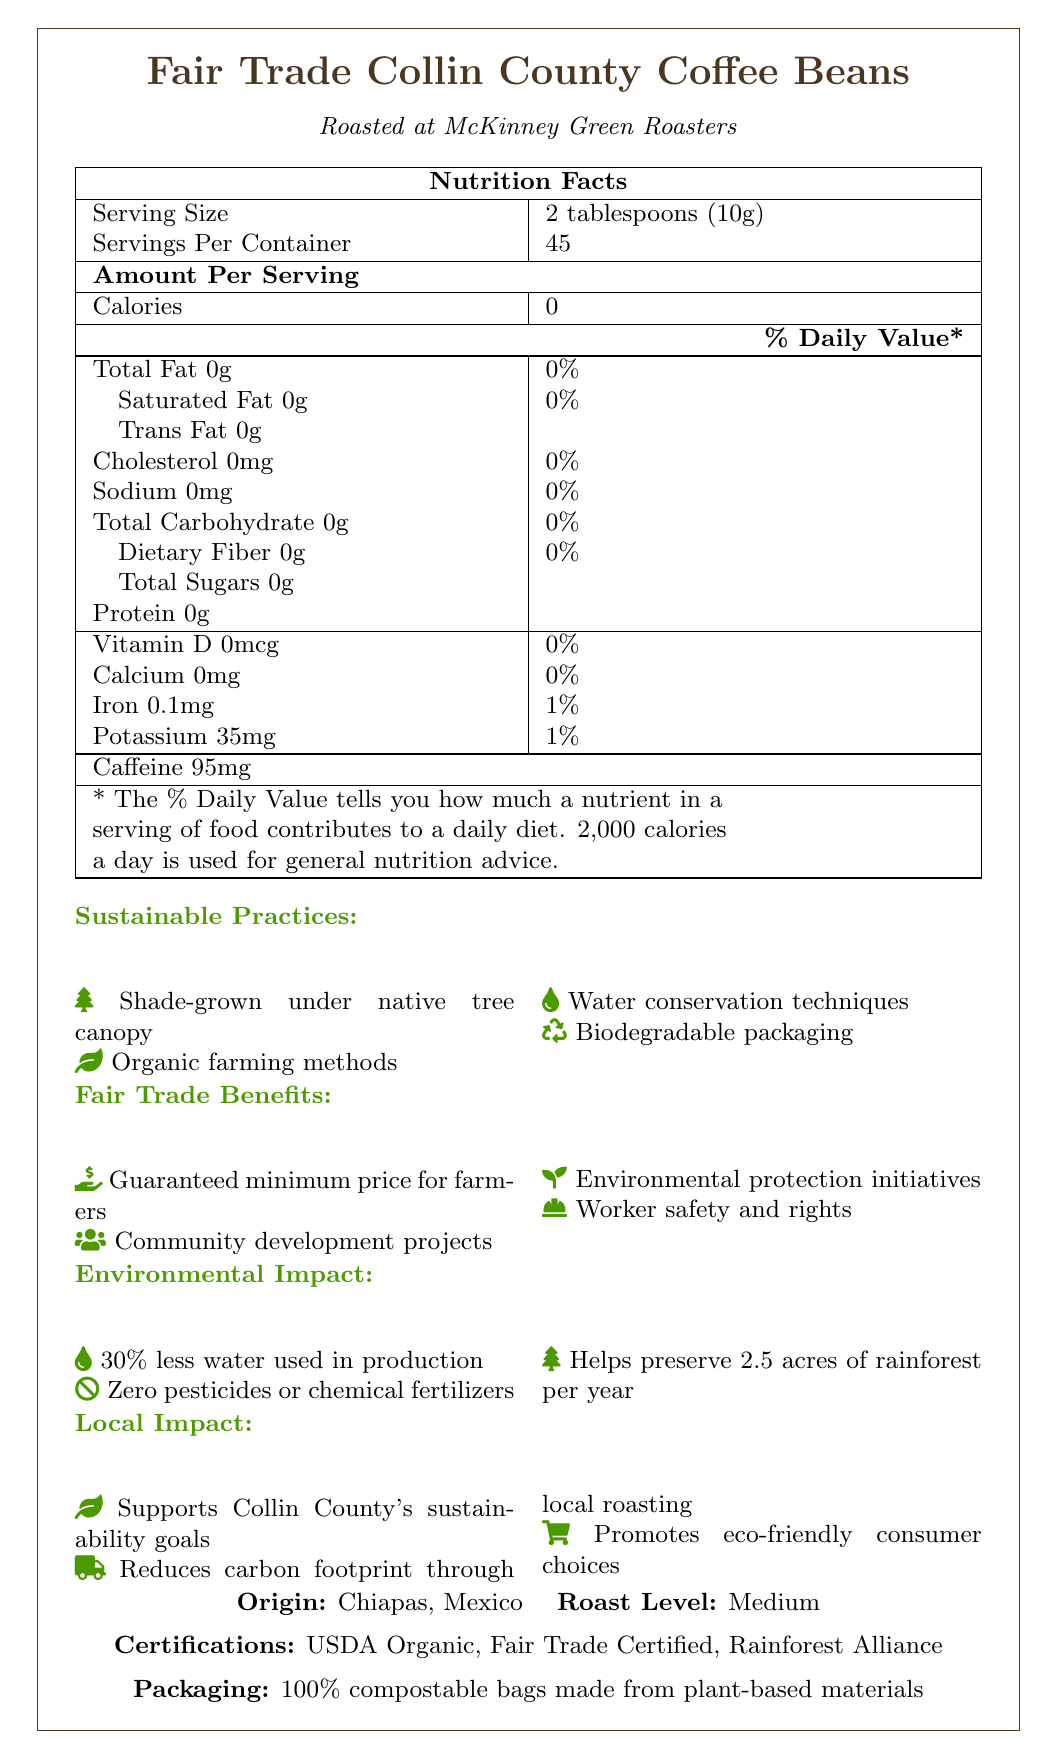what is the serving size? The serving size is clearly indicated as "2 tablespoons (10g)" in the document.
Answer: 2 tablespoons (10g) how many servings are in one container? The document lists "Servings Per Container" as 45.
Answer: 45 how many calories are in one serving of the coffee beans? The document specifies that there are "0" calories per serving.
Answer: 0 what is the amount of caffeine per serving? The "Caffeine" content is listed as "95mg" per serving.
Answer: 95mg what is the origin of the coffee beans? The origin is stated as "Chiapas, Mexico".
Answer: Chiapas, Mexico where is the coffee roasted? The document mentions that the coffee is "Roasted at McKinney Green Roasters".
Answer: McKinney Green Roasters what is the roast level of the coffee beans? The roast level is stated as "Medium".
Answer: Medium what type of packaging is used for the coffee beans? The document specifies that the packaging is "100% compostable bags made from plant-based materials".
Answer: 100% compostable bags made from plant-based materials how much potassium does one serving provide? The document lists potassium as "35mg" per serving, which is "1%" of the daily value.
Answer: 35mg (1% of daily value) what certifications does the coffee have? A. USDA Organic, Fair Trade Certified and Rainforest Alliance B. Fair Trade Certified only C. Rainforest Alliance only The document lists the certifications as "USDA Organic," "Fair Trade Certified," and "Rainforest Alliance," making option "A" the correct answer.
Answer: A which sustainable practice helps in conserving water? A. Shade-grown under native tree canopy B. Organic farming methods C. Water conservation techniques "Water conservation techniques" is explicitly listed as a sustainable practice, making option "C" correct.
Answer: C does the coffee use any pesticides or chemical fertilizers? The document states that the coffee uses "Zero pesticides or chemical fertilizers."
Answer: No what is one of the fair trade benefits mentioned? One listed fair trade benefit is the "Guaranteed minimum price for farmers."
Answer: Guaranteed minimum price for farmers describe the environmental impact of the coffee production The document indicates that the coffee production uses "30% less water," ensures "Zero pesticides or chemical fertilizers," and "Helps preserve 2.5 acres of rainforest per year."
Answer: The coffee production uses 30% less water, employs zero pesticides or chemical fertilizers, and helps preserve 2.5 acres of rainforest per year. what is the exact amount of sodium in one serving? The document lists the sodium content per serving as "0mg."
Answer: 0mg what local impact does the coffee have? The local impact is summarized as "Supports Collin County's sustainability goals," "Reduces carbon footprint through local roasting," and "Promotes eco-friendly consumer choices."
Answer: Supports Collin County's sustainability goals, reduces carbon footprint through local roasting, promotes eco-friendly consumer choices why does purchasing this coffee support farmers' communities? The document mentions that one of the fair trade benefits is "Community development projects."
Answer: Because it supports community development projects do the coffee beans help in rainforest preservation? (True/False) The document states that the coffee "Helps preserve 2.5 acres of rainforest per year."
Answer: True what is the iron content in one serving? Iron content per serving is listed as "0.1mg" which is "1%" of the daily value.
Answer: 0.1mg (1% of daily value) does the use of these coffee beans reduce the carbon footprint? The document mentions that it "Reduces carbon footprint through local roasting."
Answer: Yes where are the coffee beans grown? The document only states the origin as "Chiapas, Mexico," but does not specify other growing locations beyond this general region.
Answer: Cannot be determined how does the document emphasize environmental stewardship in coffee production? Multiple sections in the document talk about environmental-friendly practices such as "Shade-grown under native tree canopy," "Organic farming methods," "Water conservation techniques," and "Biodegradable packaging". Additionally, it mentions "Zero pesticides or chemical fertilizers" and "Helps preserve 2.5 acres of rainforest per year."
Answer: The document emphasizes environmental stewardship by highlighting sustainable practices like shade-grown methods, organic farming, water conservation, biodegradable packaging, use of zero pesticides or chemical fertilizers, and rainforest preservation. 